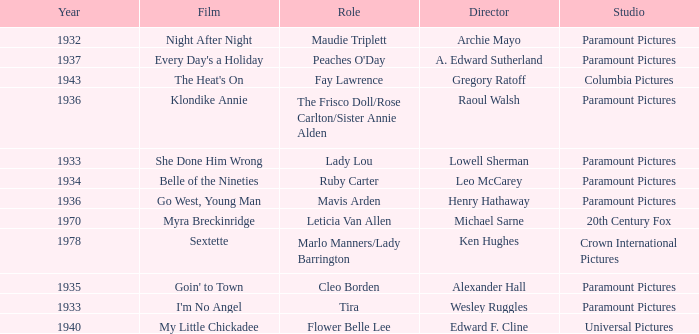What is the Year of the Film Belle of the Nineties? 1934.0. 